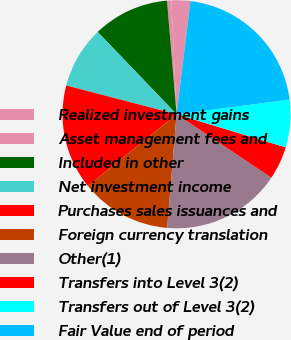<chart> <loc_0><loc_0><loc_500><loc_500><pie_chart><fcel>Realized investment gains<fcel>Asset management fees and<fcel>Included in other<fcel>Net investment income<fcel>Purchases sales issuances and<fcel>Foreign currency translation<fcel>Other(1)<fcel>Transfers into Level 3(2)<fcel>Transfers out of Level 3(2)<fcel>Fair Value end of period<nl><fcel>2.66%<fcel>0.62%<fcel>10.82%<fcel>8.78%<fcel>14.89%<fcel>12.86%<fcel>16.93%<fcel>4.7%<fcel>6.74%<fcel>21.01%<nl></chart> 